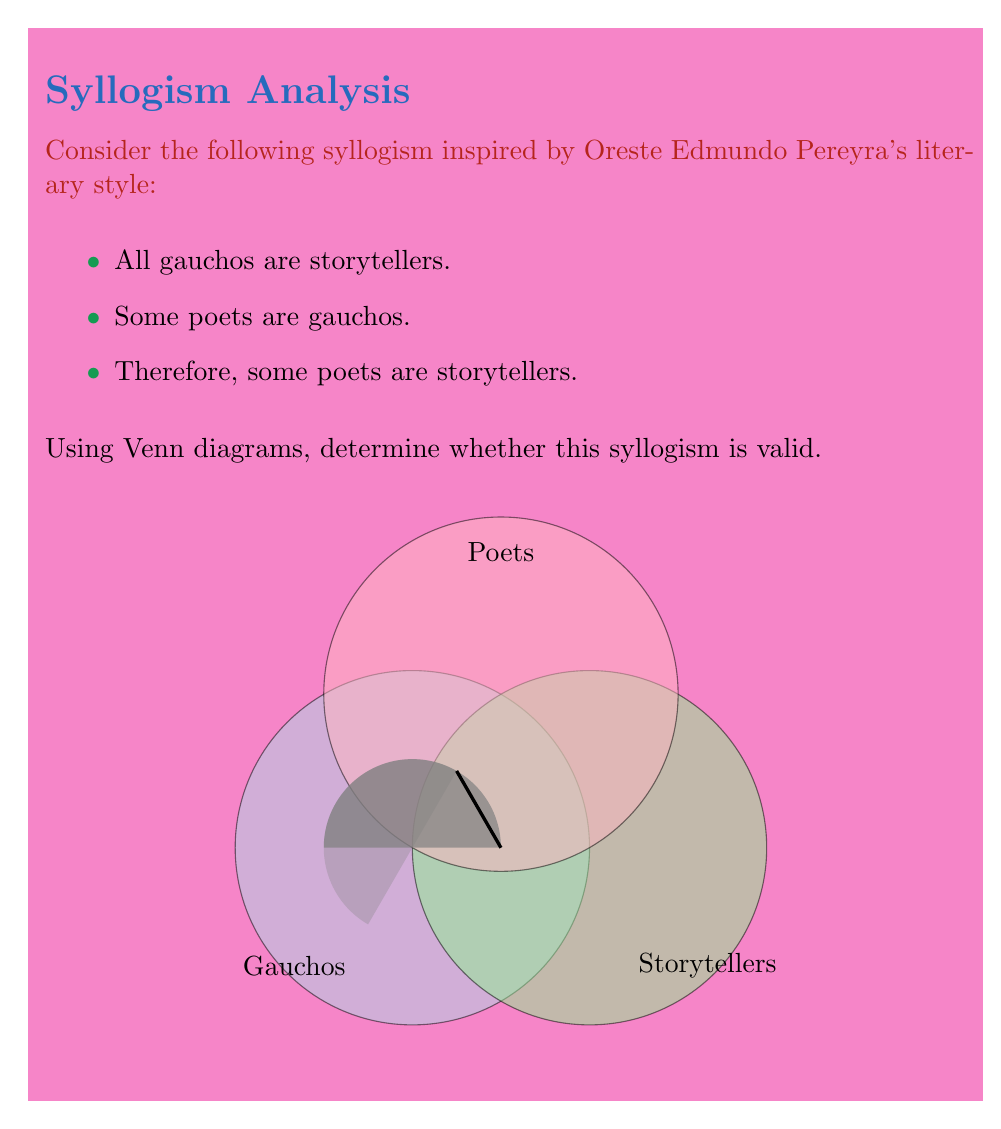Could you help me with this problem? Let's analyze this syllogism step by step using Venn diagrams:

1) First, we represent each set with a circle:
   - Gauchos (G)
   - Storytellers (S)
   - Poets (P)

2) The first premise "All gauchos are storytellers" is represented by completely including the Gauchos circle within the Storytellers circle.

3) The second premise "Some poets are gauchos" is represented by creating an overlap between the Poets circle and the Gauchos circle. We shade this area to show that it's non-empty.

4) Now, we need to check if the conclusion "Some poets are storytellers" is necessarily true based on the premises.

5) Looking at the Venn diagram, we can see that the shaded area (representing some poets who are gauchos) is entirely within the Storytellers circle.

6) This is because:
   - The shaded area is within the Gauchos circle (from premise 2)
   - The entire Gauchos circle is within the Storytellers circle (from premise 1)

7) Therefore, the shaded area (some poets) must also be within the Storytellers circle.

8) This visual representation demonstrates that the conclusion necessarily follows from the premises.

9) In formal logic terms, we can say that this syllogism is valid, as the conclusion is a logical consequence of the premises.

The Venn diagram visually proves that if the premises are true, the conclusion must also be true, regardless of the specific content of the categories involved.
Answer: Valid 